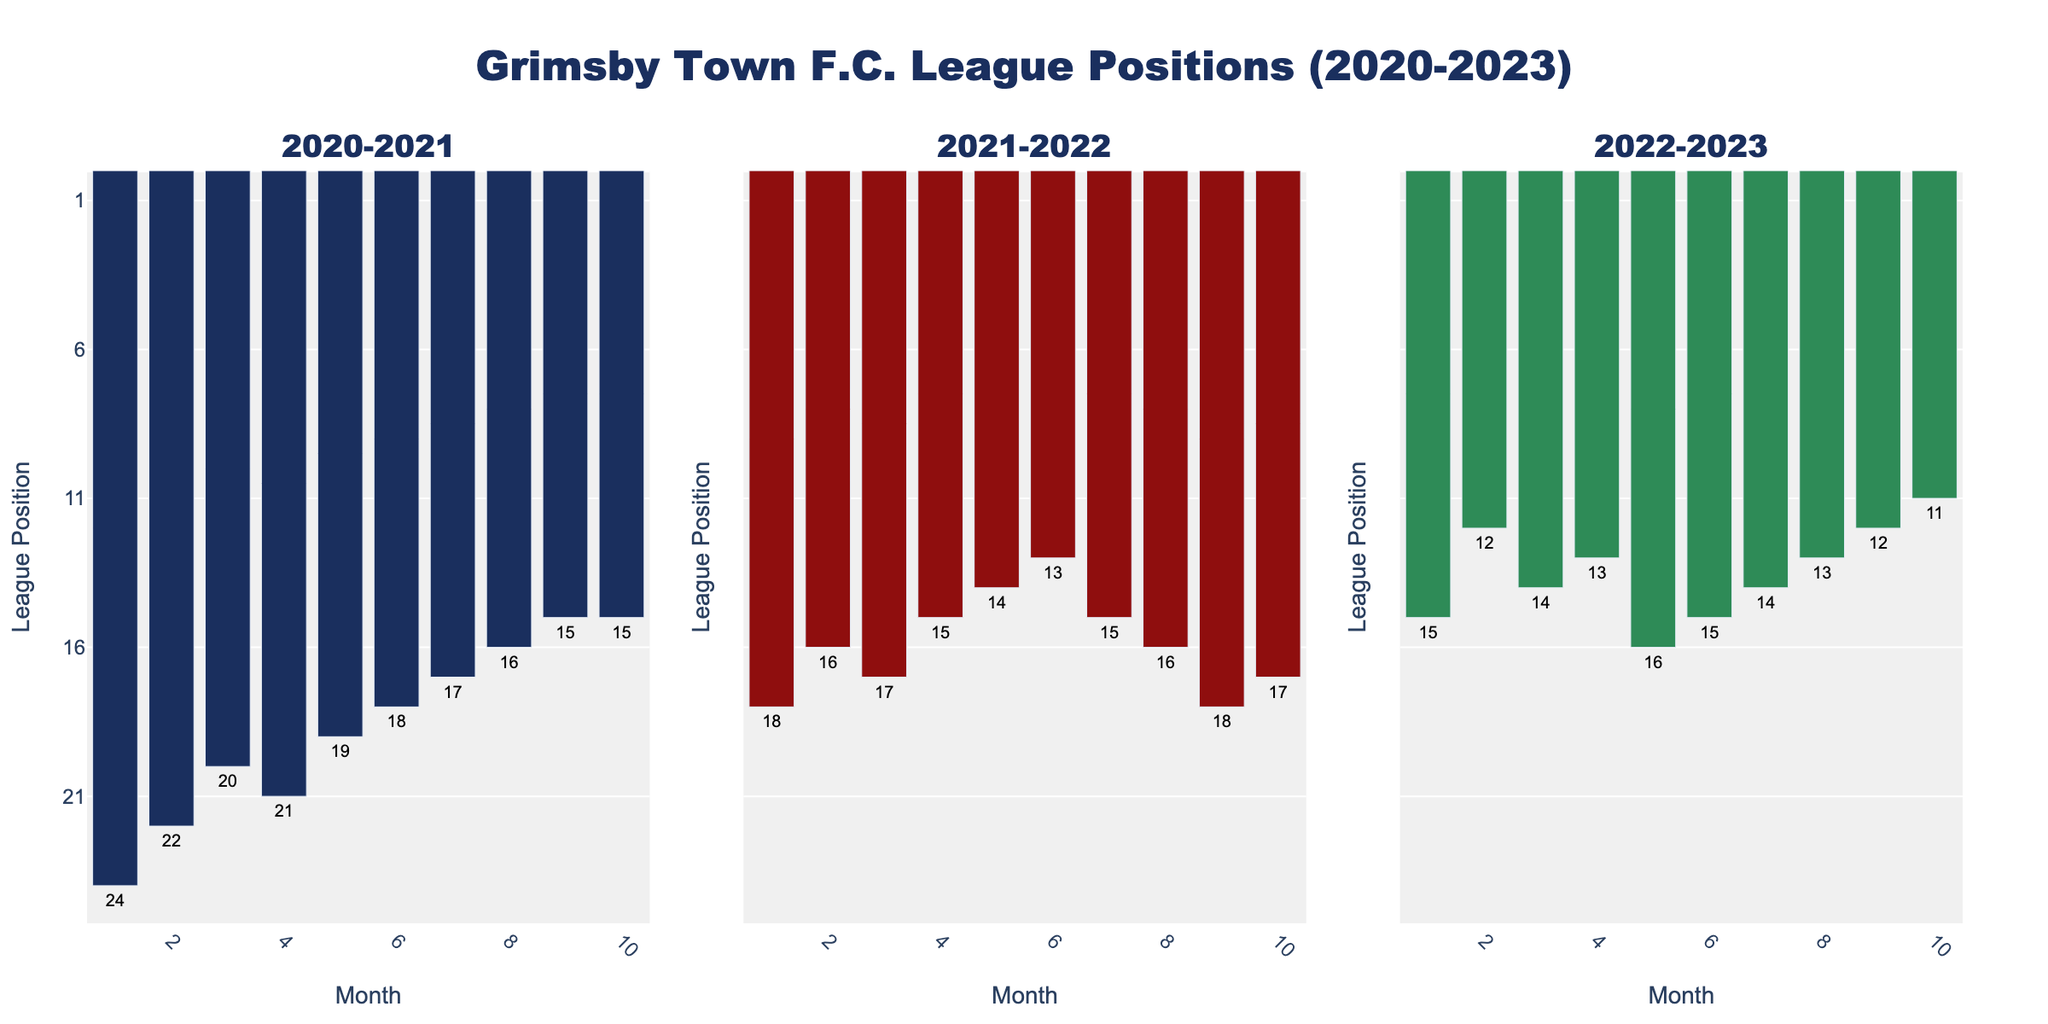What is the league position of Grimsby Town in August for the 2020-2021 season? Look at the bar corresponding to August in the subplot titled '2020-2021'. The bar reaches up to the mark labeled '24'.
Answer: 24 In which month did Grimsby Town achieve their best position in the 2022-2023 season? Look at the subplot titled '2022-2023'. The shortest bar represents the best position, occurring in May where the bar reaches '11'.
Answer: May Comparing February of 2020-2021 and 2021-2022, which season had a better position for Grimsby Town? Look at the bars corresponding to February in the subplots titled '2020-2021' and '2021-2022'. The 2021-2022 season has a shorter bar representing a lower position.
Answer: 2021-2022 What is the average league position of Grimsby Town at the end of October for all three seasons? Find the positions for October in each subplot (20, 17, 14). Calculate the average: (20 + 17 + 14)/3 = 51/3.
Answer: 17 Which season had the most consistent league position from January to March? Look at the January, February, and March bars in all subplots and observe the variations. The 2022-2023 season has positions 15, 14, 13, indicating a minimal change.
Answer: 2022-2023 When did Grimsby Town's league position first improve in the 2020-2021 season? Look at the subplot titled '2020-2021'. After August (24), the position improves in September (22).
Answer: September Which season had the highest league position in November? Compare the November bars in each subplot. In the 2020-2021 season, the bar is shortest, reflecting the highest position of 21.
Answer: 2020-2021 How many times did Grimsby Town maintain the same position over consecutive months in the 2021-2022 season? Check the 2021-2022 subplot for any two consecutive bars at the same height. No such consecutive positions are found.
Answer: 0 What is the league position difference between August and May in the 2021-2022 season? Identify the positions for August (24) and May (17) in the 2021-2022 subplot. Calculate the difference: 24 - 17 = 7.
Answer: 7 